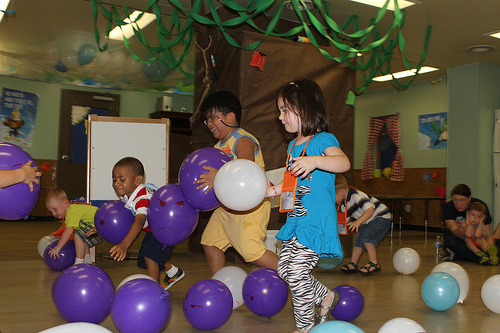<image>
Is the table behind the child? Yes. From this viewpoint, the table is positioned behind the child, with the child partially or fully occluding the table. 